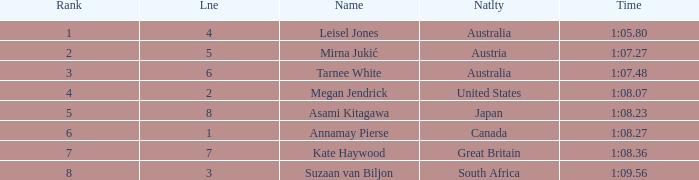What is the Nationality of the Swimmer in Lane 4 or larger with a Rank of 5 or more? Great Britain. 